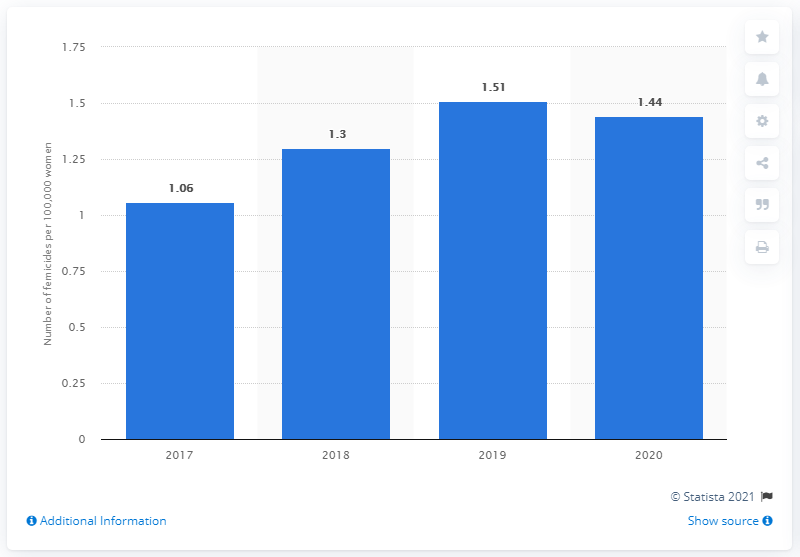Give some essential details in this illustration. In 2020, the national femicide rate in Mexico was 1.44. 